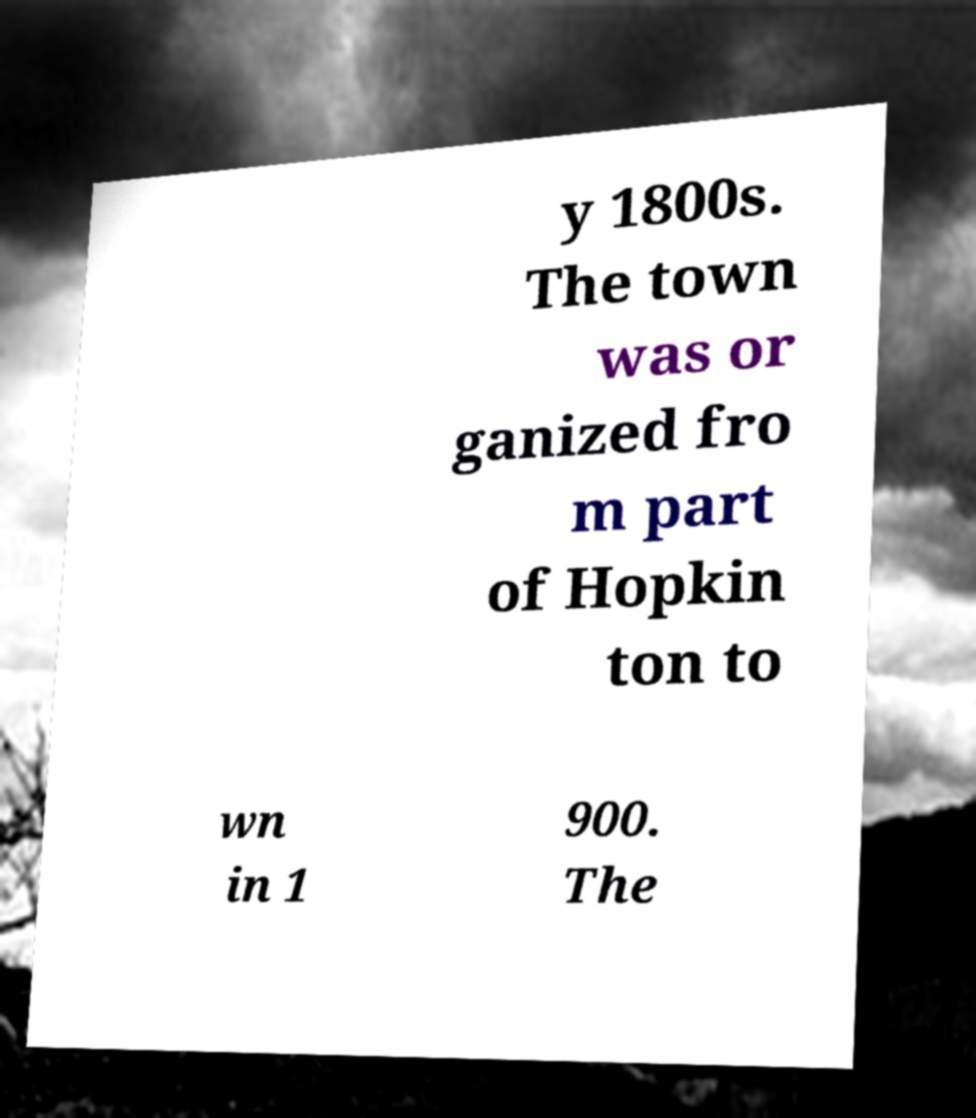Please identify and transcribe the text found in this image. y 1800s. The town was or ganized fro m part of Hopkin ton to wn in 1 900. The 